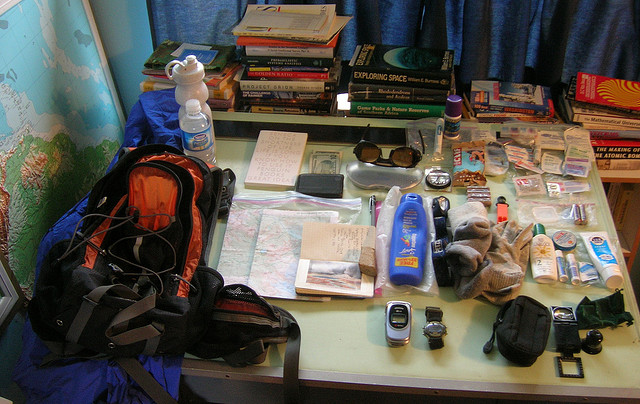How many handbags are there? There are no handbags visible in the image. The items displayed are primarily travel essentials such as maps, books, a backpack, electronics, and toiletries among other items. 